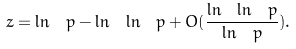<formula> <loc_0><loc_0><loc_500><loc_500>z = \ln \ p - \ln \ \ln \ p + O ( \frac { \ln \ \ln \ p } { \ln \ p } ) .</formula> 